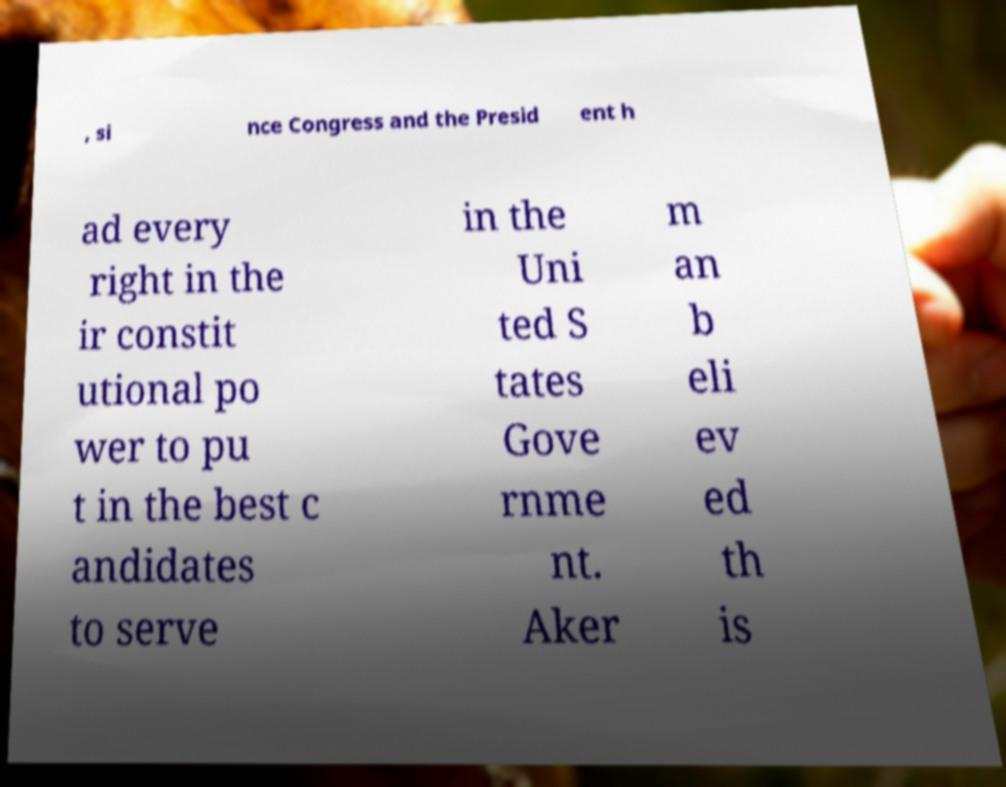Can you accurately transcribe the text from the provided image for me? , si nce Congress and the Presid ent h ad every right in the ir constit utional po wer to pu t in the best c andidates to serve in the Uni ted S tates Gove rnme nt. Aker m an b eli ev ed th is 